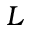Convert formula to latex. <formula><loc_0><loc_0><loc_500><loc_500>L</formula> 